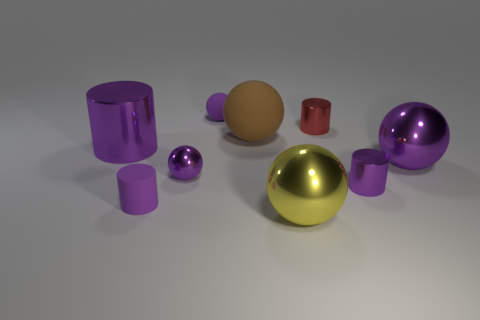Subtract all cyan balls. How many purple cylinders are left? 3 Subtract 2 cylinders. How many cylinders are left? 2 Subtract all red cylinders. How many cylinders are left? 3 Subtract all small red cylinders. How many cylinders are left? 3 Subtract all cyan cylinders. Subtract all red blocks. How many cylinders are left? 4 Add 1 matte blocks. How many objects exist? 10 Subtract all cylinders. How many objects are left? 5 Subtract 0 blue balls. How many objects are left? 9 Subtract all large purple metal cylinders. Subtract all tiny metal cylinders. How many objects are left? 6 Add 7 big yellow balls. How many big yellow balls are left? 8 